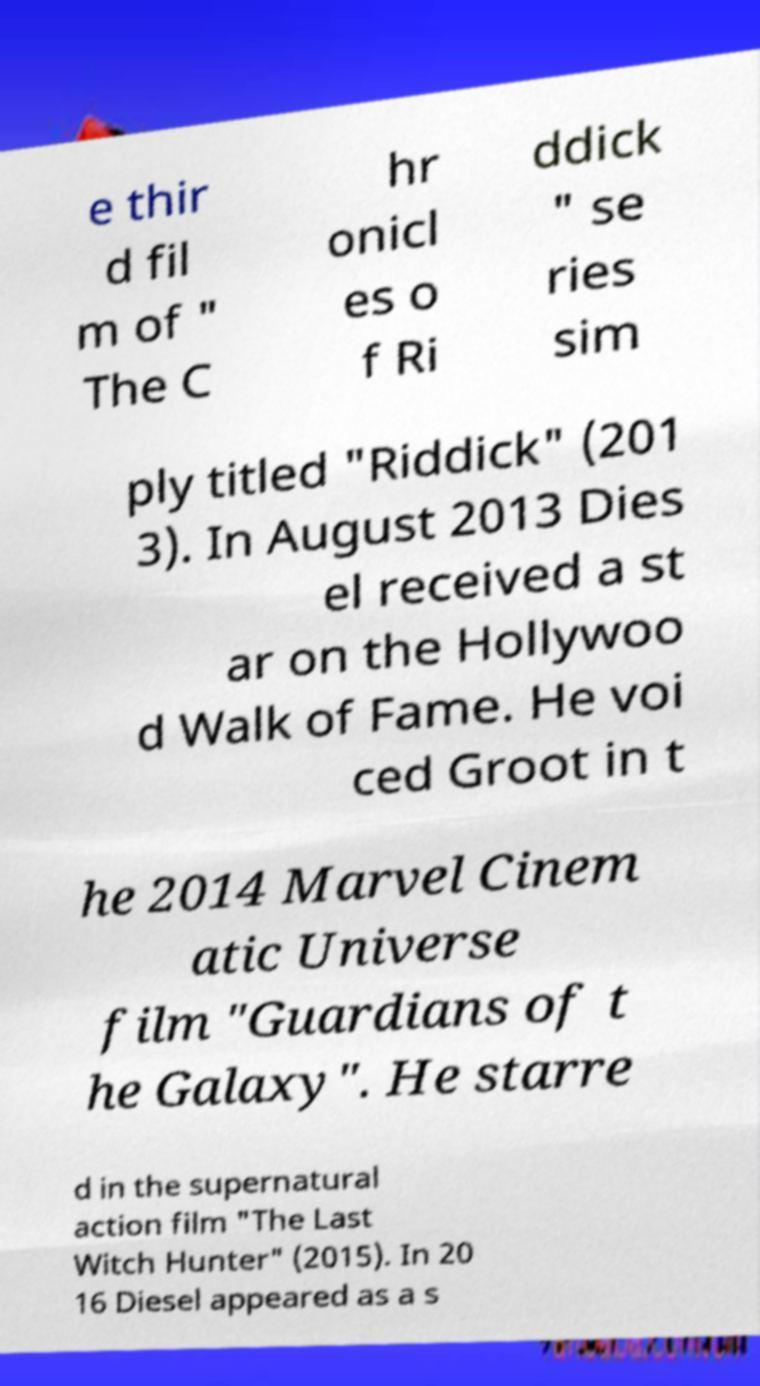Please read and relay the text visible in this image. What does it say? e thir d fil m of " The C hr onicl es o f Ri ddick " se ries sim ply titled "Riddick" (201 3). In August 2013 Dies el received a st ar on the Hollywoo d Walk of Fame. He voi ced Groot in t he 2014 Marvel Cinem atic Universe film "Guardians of t he Galaxy". He starre d in the supernatural action film "The Last Witch Hunter" (2015). In 20 16 Diesel appeared as a s 